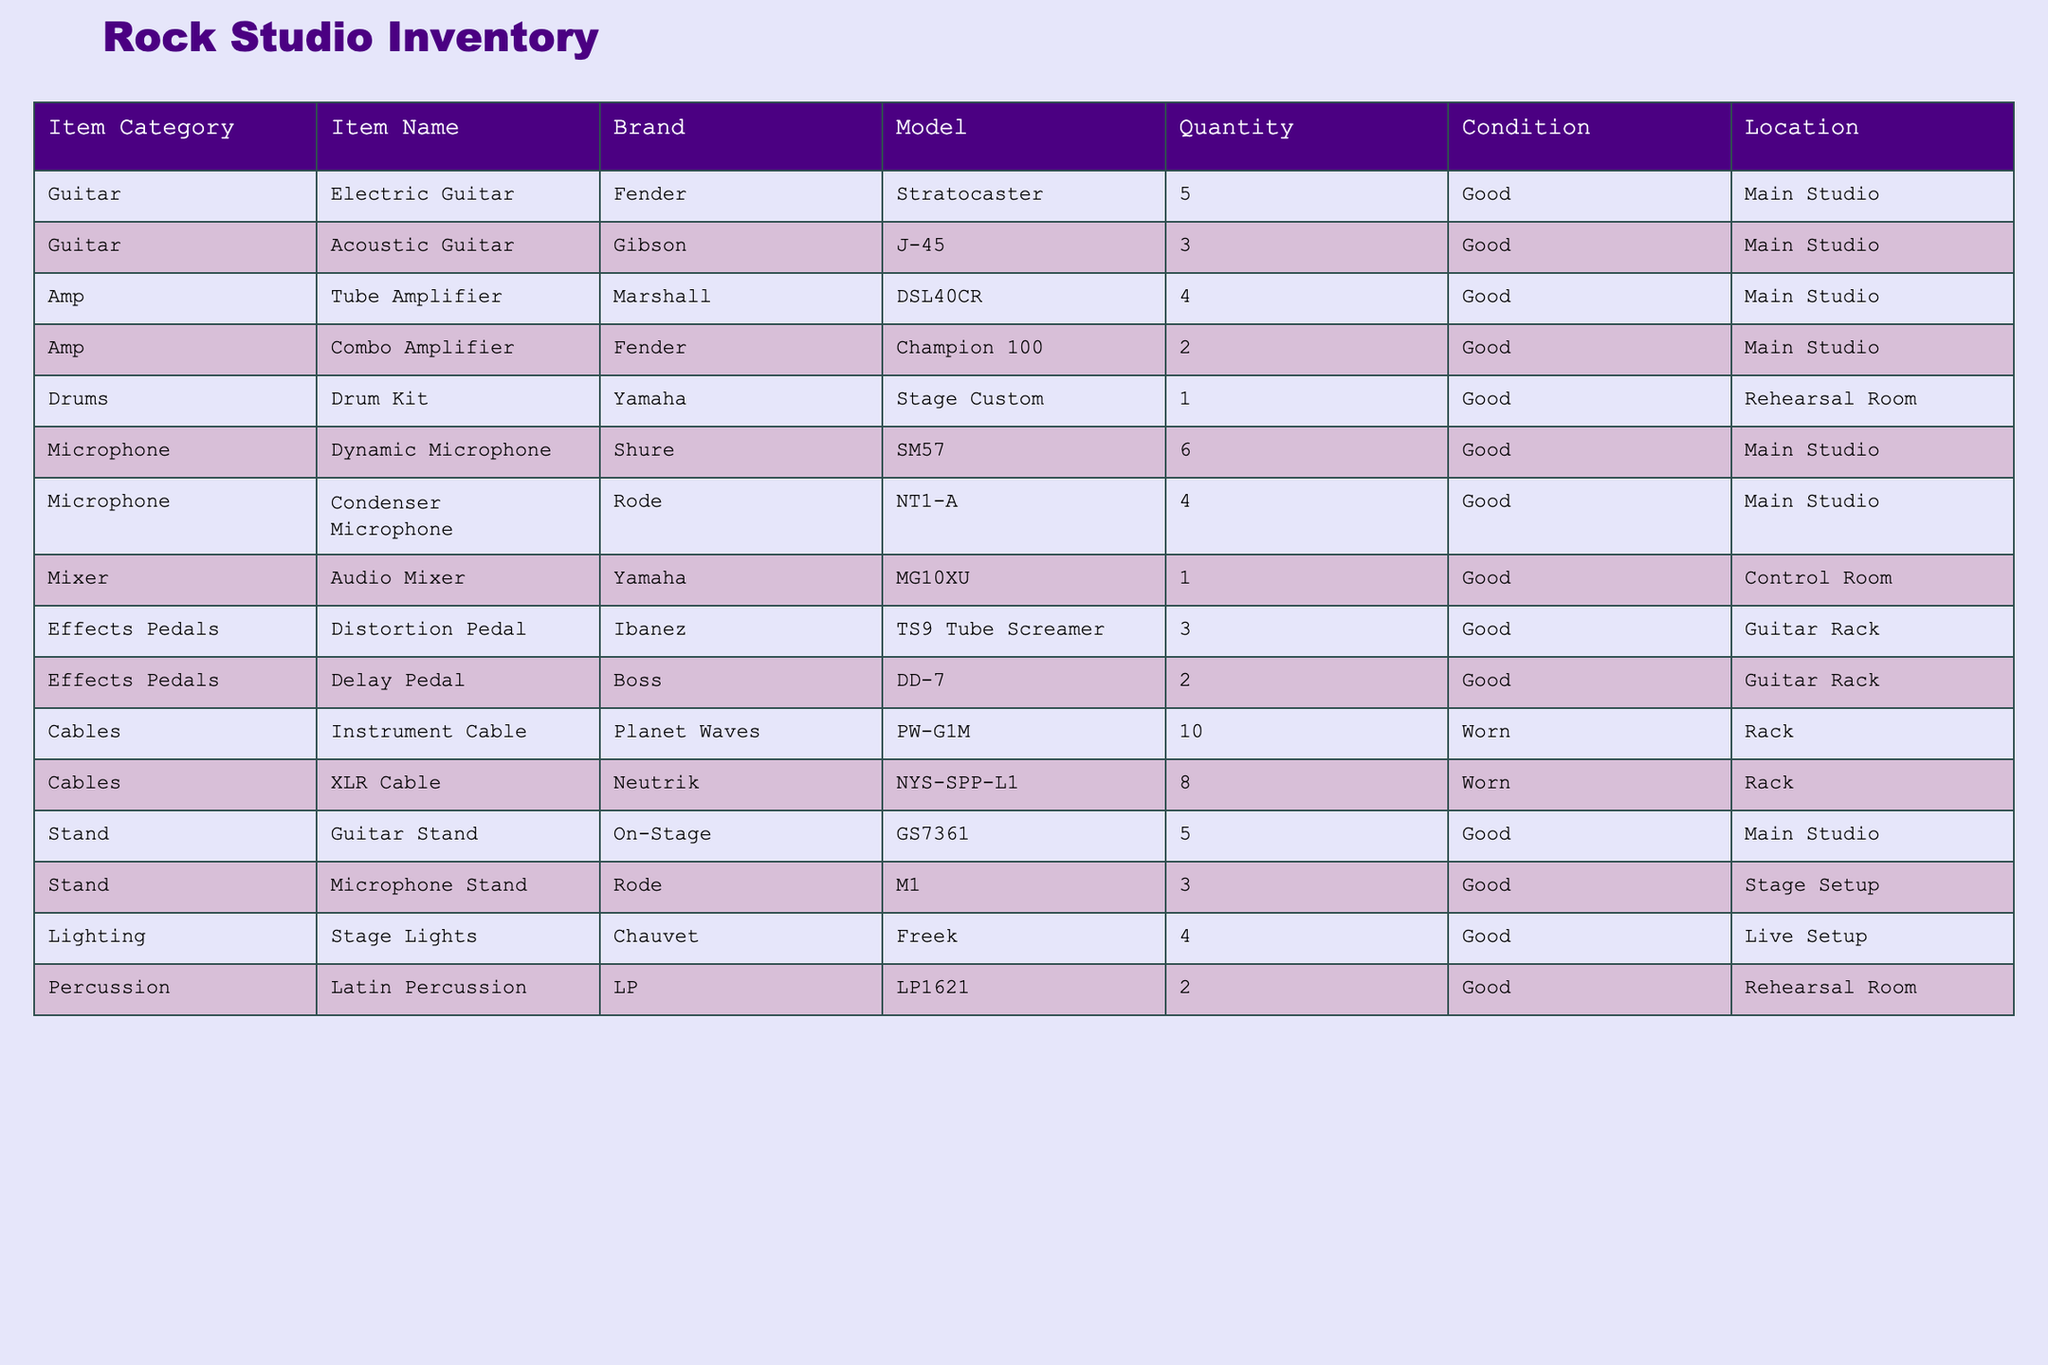What is the total number of electric guitars in the inventory? The table indicates that there are 5 electric guitars listed under the "Electric Guitar" category. Therefore, the total number of electric guitars is simply 5.
Answer: 5 How many dynamic microphones does the studio have compared to condenser microphones? The table states that there are 6 dynamic microphones and 4 condenser microphones. The difference is calculated by subtracting the number of condenser microphones from dynamic microphones: 6 - 4 = 2. Hence, there are 2 more dynamic microphones than condenser microphones.
Answer: 2 Is there any guitar stand located in the rehearsal room? The table shows that all guitar stands are located in the "Main Studio". Therefore, there are no guitar stands in the rehearsal room, which makes this statement false.
Answer: No What percentage of the inventory is composed of effects pedals? The total number of items in the inventory is 37 (summing up the quantities: 5 + 3 + 4 + 2 + 1 + 6 + 4 + 1 + 3 + 2 + 10 + 8 + 5 + 3 + 4 + 2 = 37). The total number of effects pedals is 5 (3 distortion + 2 delay). Therefore, the percentage is (5/37) * 100 = approximately 13.51%, which we can round off to 13.5%.
Answer: 13.5% Which item category has the highest quantity available? By examining the quantities in the table, we see that the category with the highest quantity is "Cables", which has a total of 18 items (10 instrument cables + 8 XLR cables). No other category has a higher total.
Answer: Cables How many items are in good condition versus worn condition? The table indicates that there are 28 items in good condition (summing all good quality items) and 18 items in worn condition (10 instrument cables + 8 XLR cables). Hence, there are more items in good condition than in worn condition.
Answer: 28 good, 10 worn 